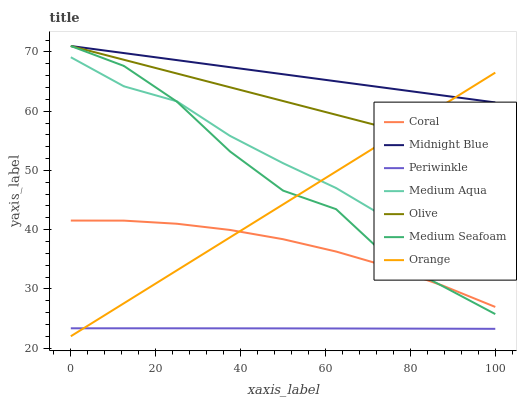Does Periwinkle have the minimum area under the curve?
Answer yes or no. Yes. Does Midnight Blue have the maximum area under the curve?
Answer yes or no. Yes. Does Coral have the minimum area under the curve?
Answer yes or no. No. Does Coral have the maximum area under the curve?
Answer yes or no. No. Is Midnight Blue the smoothest?
Answer yes or no. Yes. Is Medium Seafoam the roughest?
Answer yes or no. Yes. Is Coral the smoothest?
Answer yes or no. No. Is Coral the roughest?
Answer yes or no. No. Does Orange have the lowest value?
Answer yes or no. Yes. Does Coral have the lowest value?
Answer yes or no. No. Does Medium Seafoam have the highest value?
Answer yes or no. Yes. Does Coral have the highest value?
Answer yes or no. No. Is Medium Aqua less than Olive?
Answer yes or no. Yes. Is Medium Seafoam greater than Periwinkle?
Answer yes or no. Yes. Does Periwinkle intersect Orange?
Answer yes or no. Yes. Is Periwinkle less than Orange?
Answer yes or no. No. Is Periwinkle greater than Orange?
Answer yes or no. No. Does Medium Aqua intersect Olive?
Answer yes or no. No. 